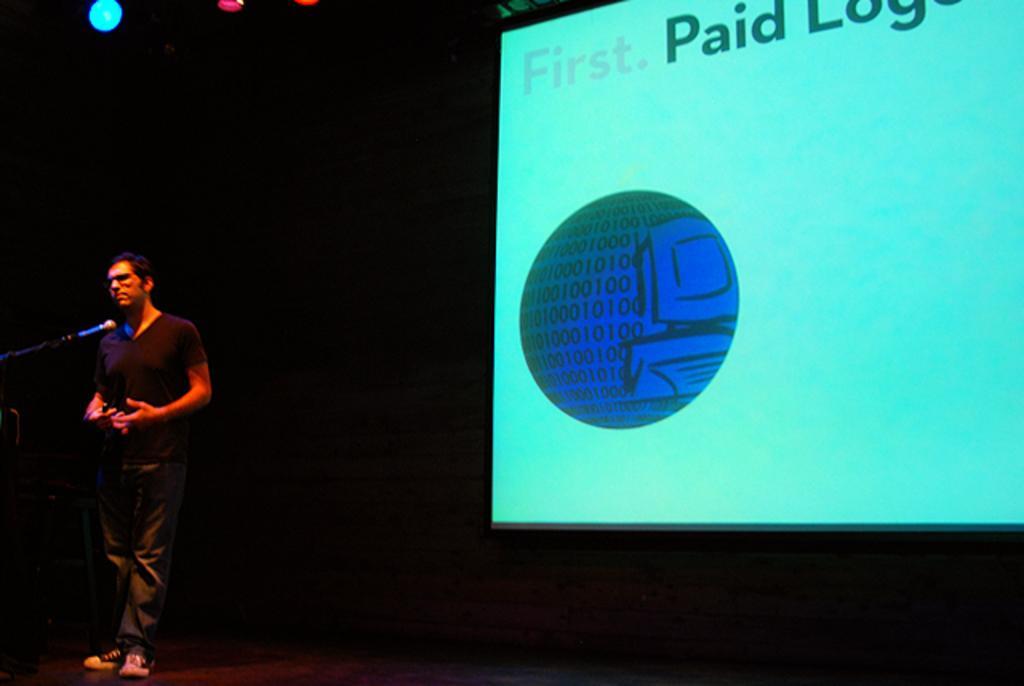Could you give a brief overview of what you see in this image? On the left there is a man standing on the stage and there is a mike. In the background there are lights and screen. 